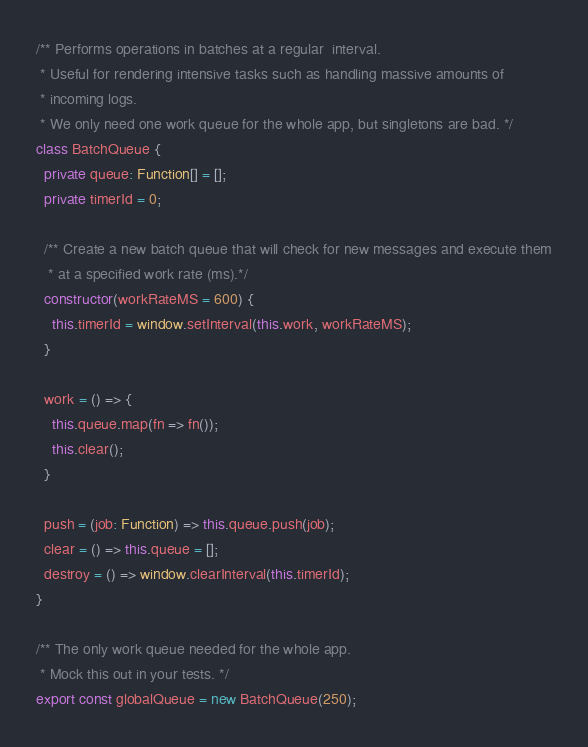Convert code to text. <code><loc_0><loc_0><loc_500><loc_500><_TypeScript_>/** Performs operations in batches at a regular  interval.
 * Useful for rendering intensive tasks such as handling massive amounts of
 * incoming logs.
 * We only need one work queue for the whole app, but singletons are bad. */
class BatchQueue {
  private queue: Function[] = [];
  private timerId = 0;

  /** Create a new batch queue that will check for new messages and execute them
   * at a specified work rate (ms).*/
  constructor(workRateMS = 600) {
    this.timerId = window.setInterval(this.work, workRateMS);
  }

  work = () => {
    this.queue.map(fn => fn());
    this.clear();
  }

  push = (job: Function) => this.queue.push(job);
  clear = () => this.queue = [];
  destroy = () => window.clearInterval(this.timerId);
}

/** The only work queue needed for the whole app.
 * Mock this out in your tests. */
export const globalQueue = new BatchQueue(250);
</code> 